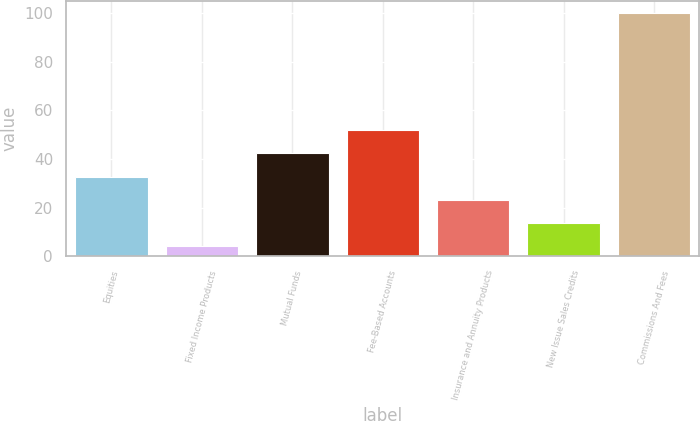<chart> <loc_0><loc_0><loc_500><loc_500><bar_chart><fcel>Equities<fcel>Fixed Income Products<fcel>Mutual Funds<fcel>Fee-Based Accounts<fcel>Insurance and Annuity Products<fcel>New Issue Sales Credits<fcel>Commissions And Fees<nl><fcel>32.8<fcel>4<fcel>42.4<fcel>52<fcel>23.2<fcel>13.6<fcel>100<nl></chart> 